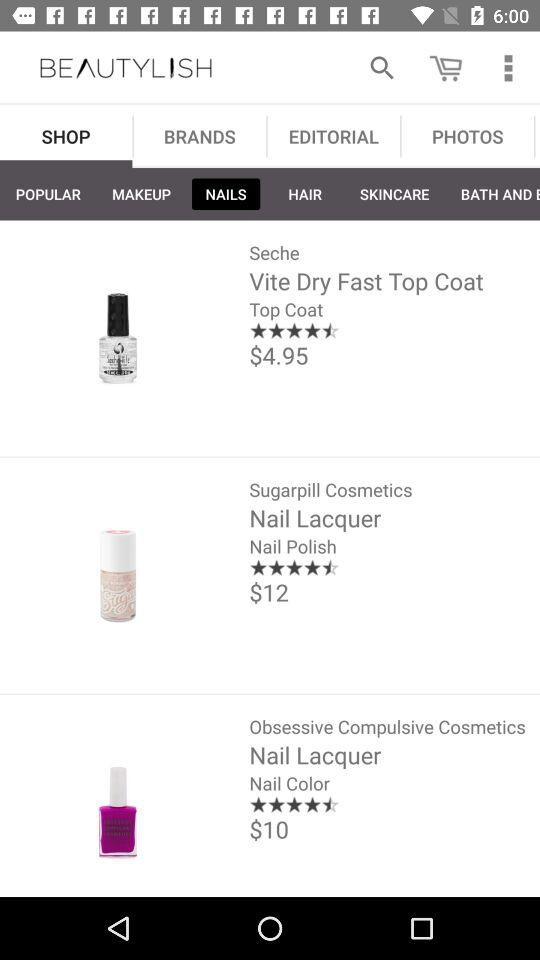What is the name of the application? The name of the application is "BEAUTYLISH". 